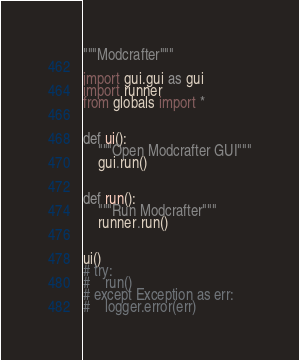Convert code to text. <code><loc_0><loc_0><loc_500><loc_500><_Python_>"""Modcrafter"""

import gui.gui as gui
import runner
from globals import *


def ui():
    """Open Modcrafter GUI"""
    gui.run()


def run():
    """Run Modcrafter"""
    runner.run()


ui()
# try:
#    run()
# except Exception as err:
#    logger.error(err)
</code> 